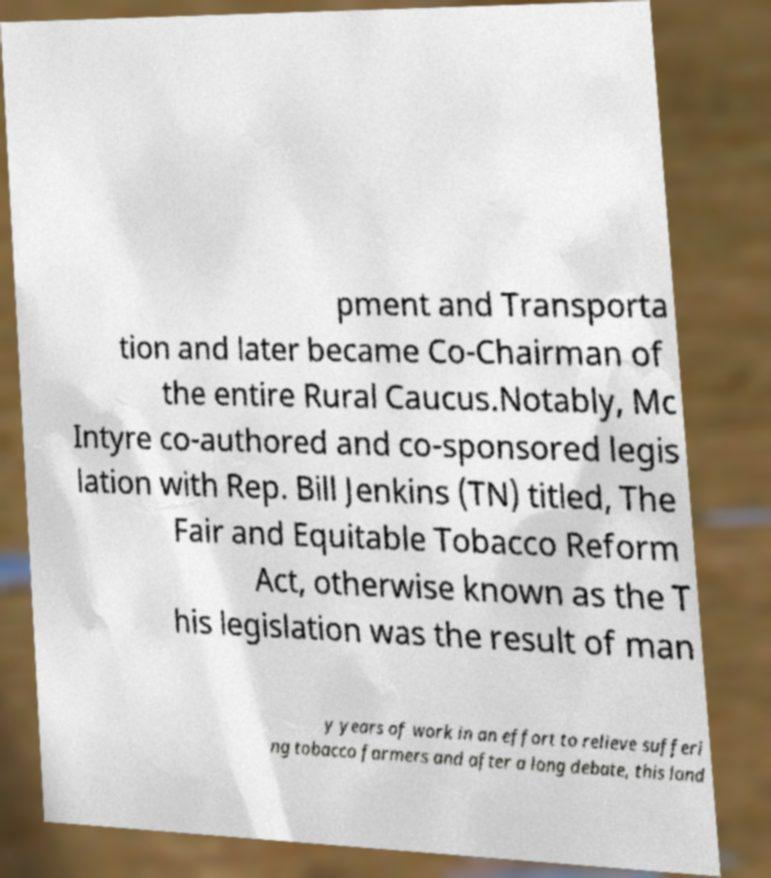Could you extract and type out the text from this image? pment and Transporta tion and later became Co-Chairman of the entire Rural Caucus.Notably, Mc Intyre co-authored and co-sponsored legis lation with Rep. Bill Jenkins (TN) titled, The Fair and Equitable Tobacco Reform Act, otherwise known as the T his legislation was the result of man y years of work in an effort to relieve sufferi ng tobacco farmers and after a long debate, this land 